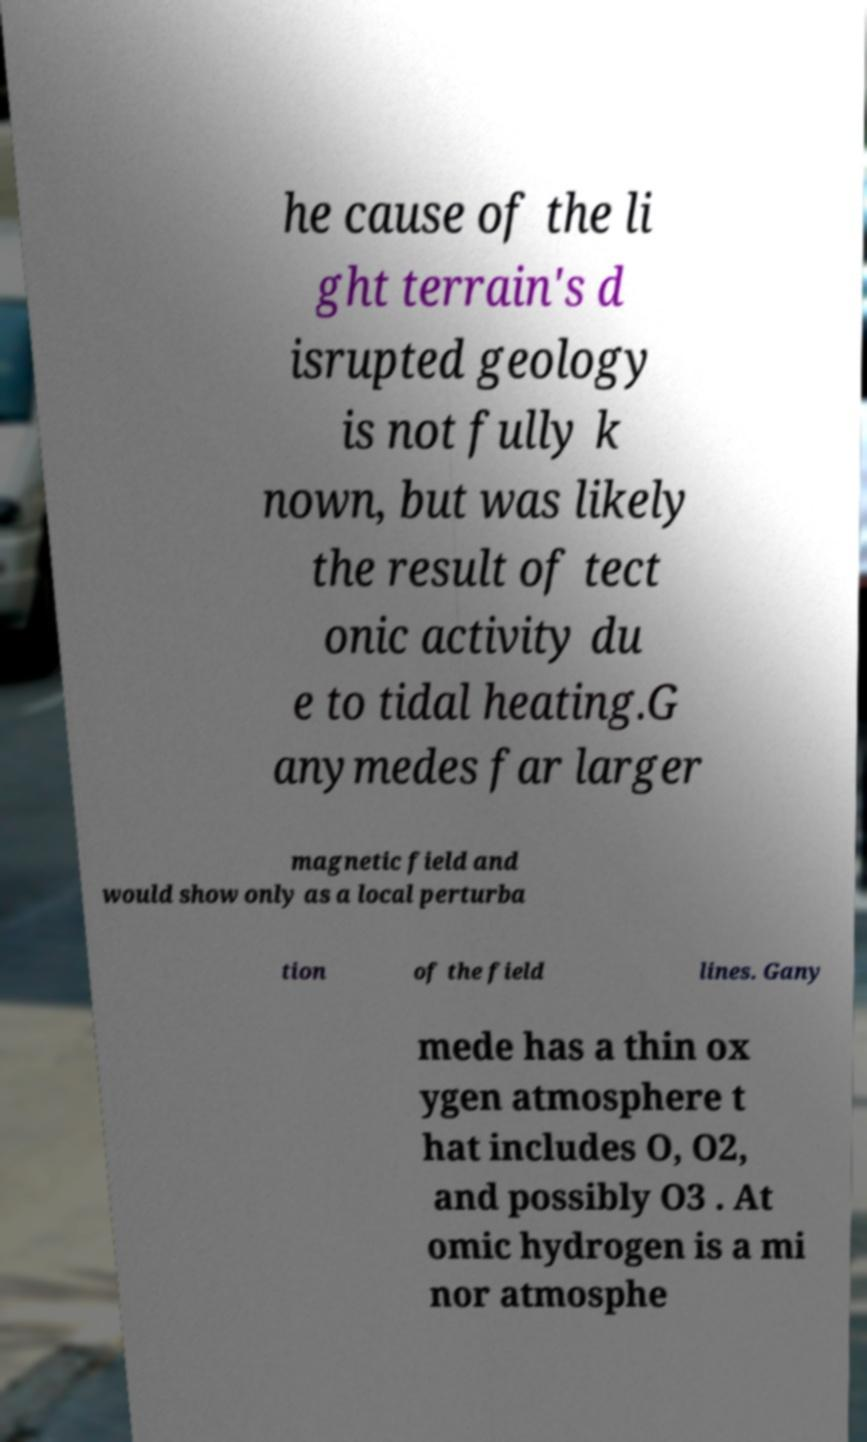For documentation purposes, I need the text within this image transcribed. Could you provide that? he cause of the li ght terrain's d isrupted geology is not fully k nown, but was likely the result of tect onic activity du e to tidal heating.G anymedes far larger magnetic field and would show only as a local perturba tion of the field lines. Gany mede has a thin ox ygen atmosphere t hat includes O, O2, and possibly O3 . At omic hydrogen is a mi nor atmosphe 